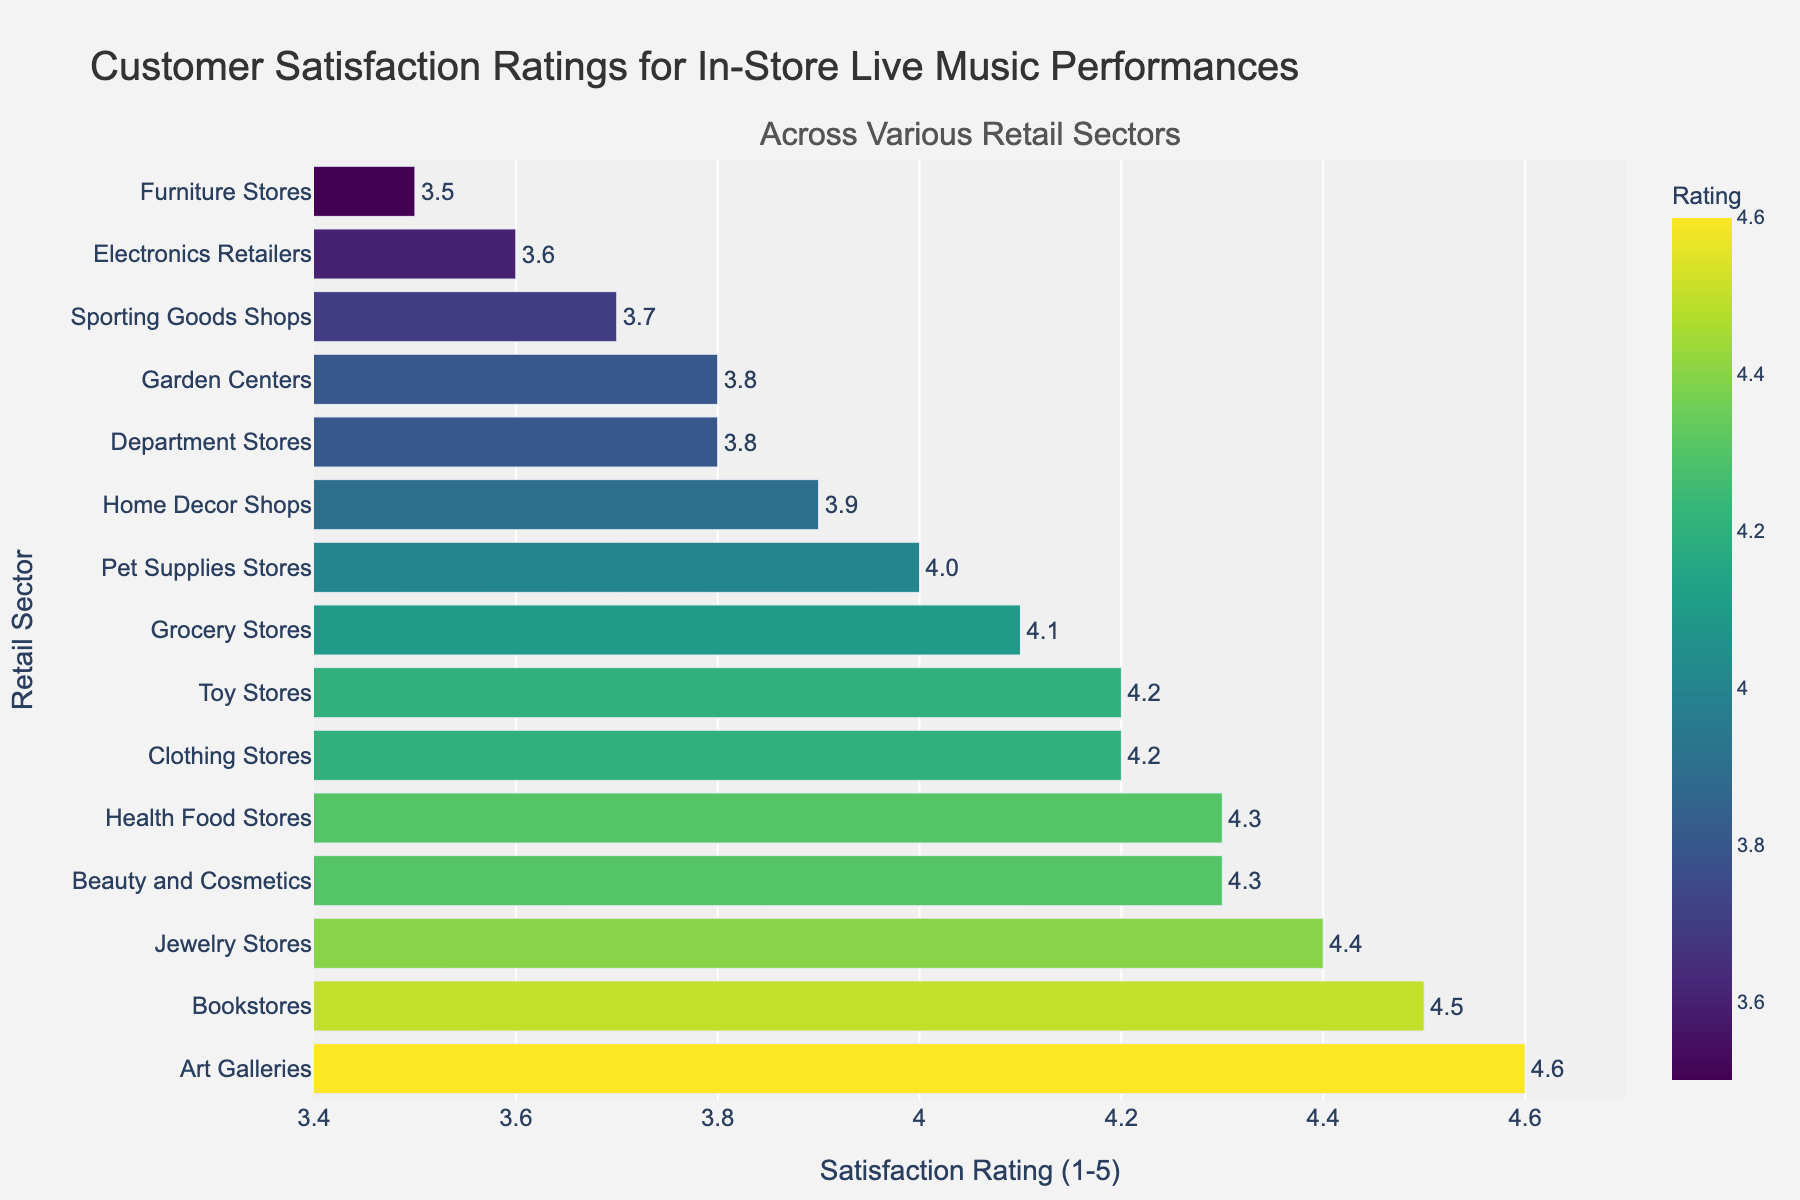Which retail sector has the highest customer satisfaction rating? The bar representing "Art Galleries" is the tallest, indicating the highest rating.
Answer: Art Galleries Which retail sector has the lowest customer satisfaction rating? The bar representing "Furniture Stores" is the shortest, indicating the lowest rating.
Answer: Furniture Stores What's the difference between the highest and lowest satisfaction ratings? The highest rating is 4.6 (Art Galleries) and the lowest is 3.5 (Furniture Stores). The difference is 4.6 - 3.5 = 1.1.
Answer: 1.1 Is the average customer satisfaction rating for Grocery Stores higher than that for Home Decor Shops? The bar for Grocery Stores is taller than the one for Home Decor Shops, indicating a higher rating for Grocery Stores.
Answer: Yes Which sector has a higher rating: Sporting Goods Shops or Department Stores? The bar for Sporting Goods Shops is slightly taller than the one for Department Stores, indicating a higher rating for Sporting Goods Shops.
Answer: Sporting Goods Shops What's the sum of the customer satisfaction ratings for Clothing Stores, Bookstores, and Jewelry Stores? Summing the ratings: 4.2 (Clothing Stores) + 4.5 (Bookstores) + 4.4 (Jewelry Stores) = 13.1.
Answer: 13.1 On average, do the ratings for Pet Supplies Stores and Health Food Stores exceed 4.0? The ratings are 4.0 (Pet Supplies Stores) and 4.3 (Health Food Stores); the average is (4.0 + 4.3) / 2 = 4.15, which exceeds 4.0.
Answer: Yes Between Clothing Stores and Toy Stores, which sector has a higher customer satisfaction rating? Both Clothing Stores and Toy Stores have the same rating of 4.2, so neither is higher.
Answer: Equal What is the median value of customer satisfaction ratings for all retail sectors? To find the median: sort the ratings and select the middle value. The sorted list gives 3.5, 3.6, 3.7, 3.8, 3.8, 3.9, 4.0, 4.1, 4.2, 4.2, 4.3, 4.3, 4.4, 4.5, 4.6. The median rating (middle value) is 4.0.
Answer: 4.0 